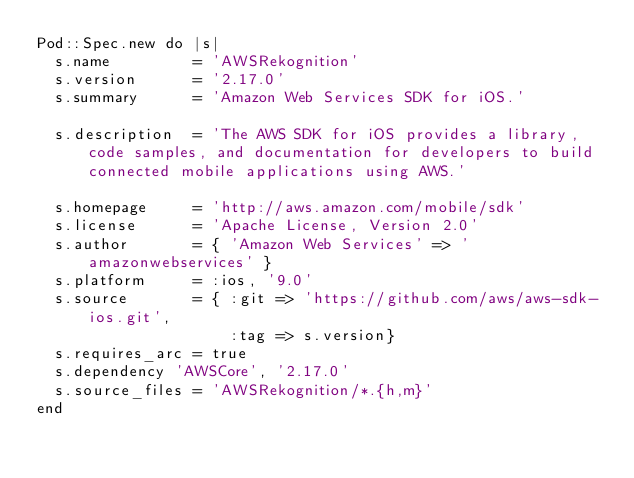<code> <loc_0><loc_0><loc_500><loc_500><_Ruby_>Pod::Spec.new do |s|
  s.name         = 'AWSRekognition'
  s.version      = '2.17.0'
  s.summary      = 'Amazon Web Services SDK for iOS.'

  s.description  = 'The AWS SDK for iOS provides a library, code samples, and documentation for developers to build connected mobile applications using AWS.'

  s.homepage     = 'http://aws.amazon.com/mobile/sdk'
  s.license      = 'Apache License, Version 2.0'
  s.author       = { 'Amazon Web Services' => 'amazonwebservices' }
  s.platform     = :ios, '9.0'
  s.source       = { :git => 'https://github.com/aws/aws-sdk-ios.git',
                     :tag => s.version}
  s.requires_arc = true
  s.dependency 'AWSCore', '2.17.0'
  s.source_files = 'AWSRekognition/*.{h,m}'
end
</code> 